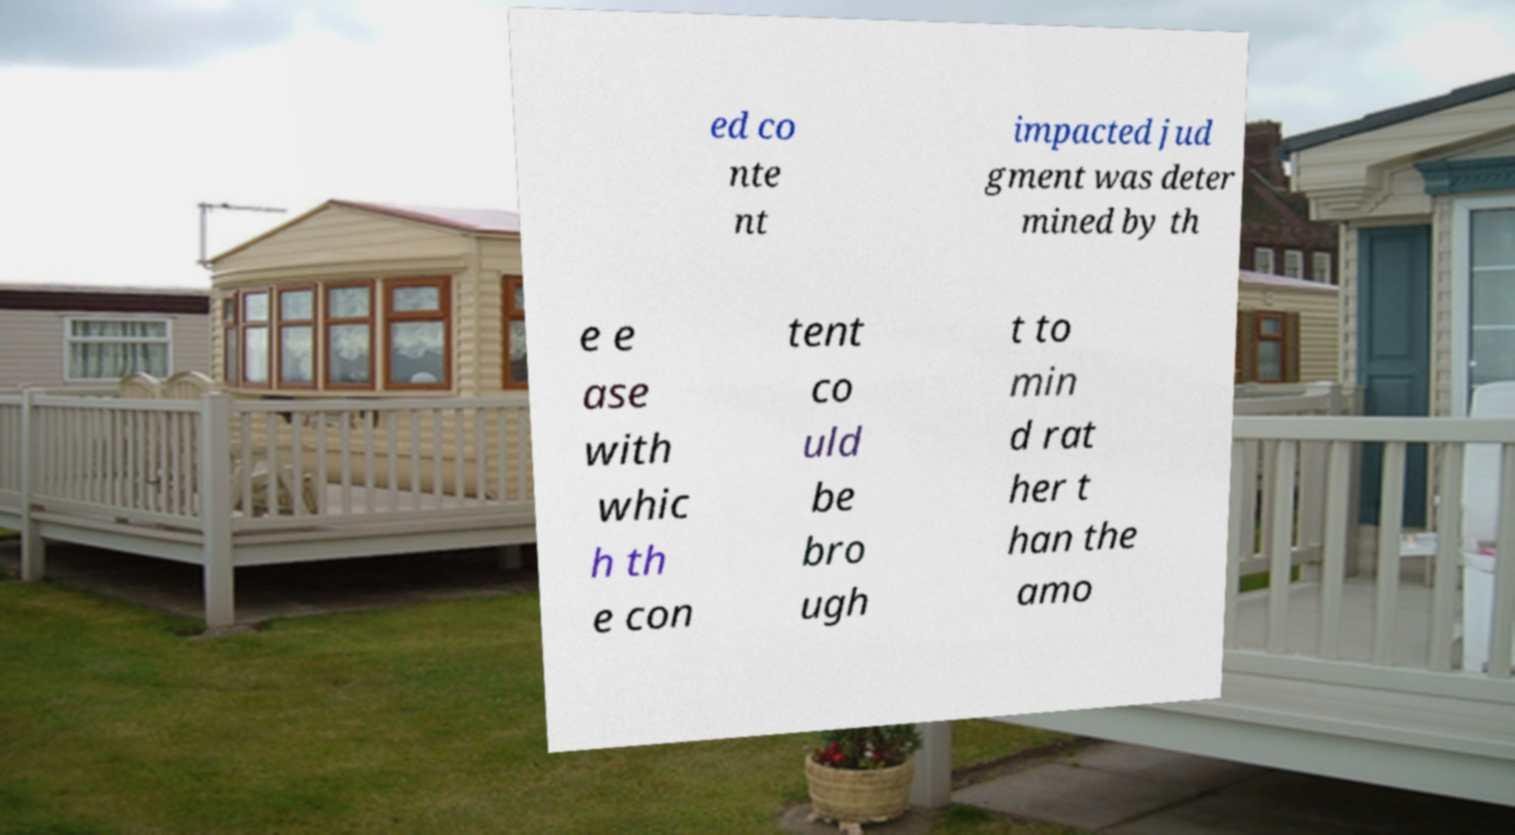Please read and relay the text visible in this image. What does it say? ed co nte nt impacted jud gment was deter mined by th e e ase with whic h th e con tent co uld be bro ugh t to min d rat her t han the amo 